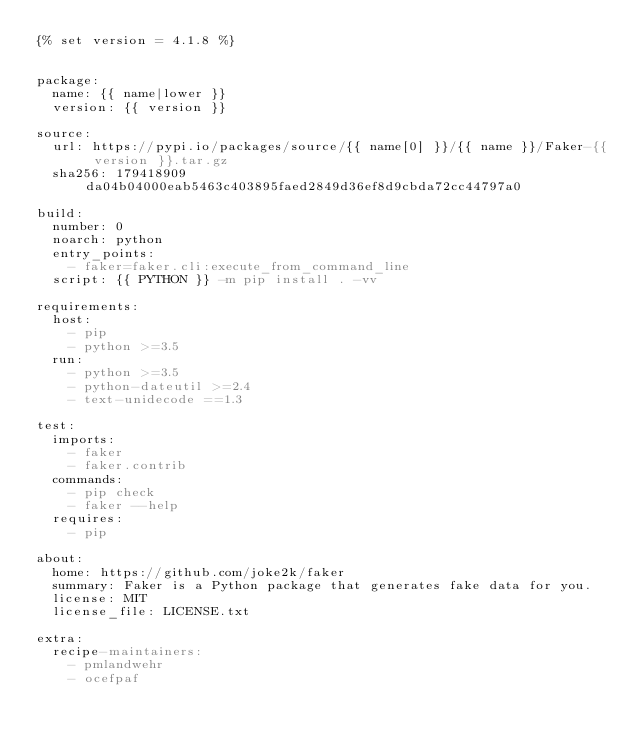Convert code to text. <code><loc_0><loc_0><loc_500><loc_500><_YAML_>{% set version = 4.1.8 %}


package:
  name: {{ name|lower }}
  version: {{ version }}

source:
  url: https://pypi.io/packages/source/{{ name[0] }}/{{ name }}/Faker-{{ version }}.tar.gz
  sha256: 179418909da04b04000eab5463c403895faed2849d36ef8d9cbda72cc44797a0

build:
  number: 0
  noarch: python
  entry_points:
    - faker=faker.cli:execute_from_command_line
  script: {{ PYTHON }} -m pip install . -vv

requirements:
  host:
    - pip
    - python >=3.5
  run:
    - python >=3.5
    - python-dateutil >=2.4
    - text-unidecode ==1.3

test:
  imports:
    - faker
    - faker.contrib
  commands:
    - pip check
    - faker --help
  requires:
    - pip

about:
  home: https://github.com/joke2k/faker
  summary: Faker is a Python package that generates fake data for you.
  license: MIT
  license_file: LICENSE.txt

extra:
  recipe-maintainers:
    - pmlandwehr
    - ocefpaf
</code> 